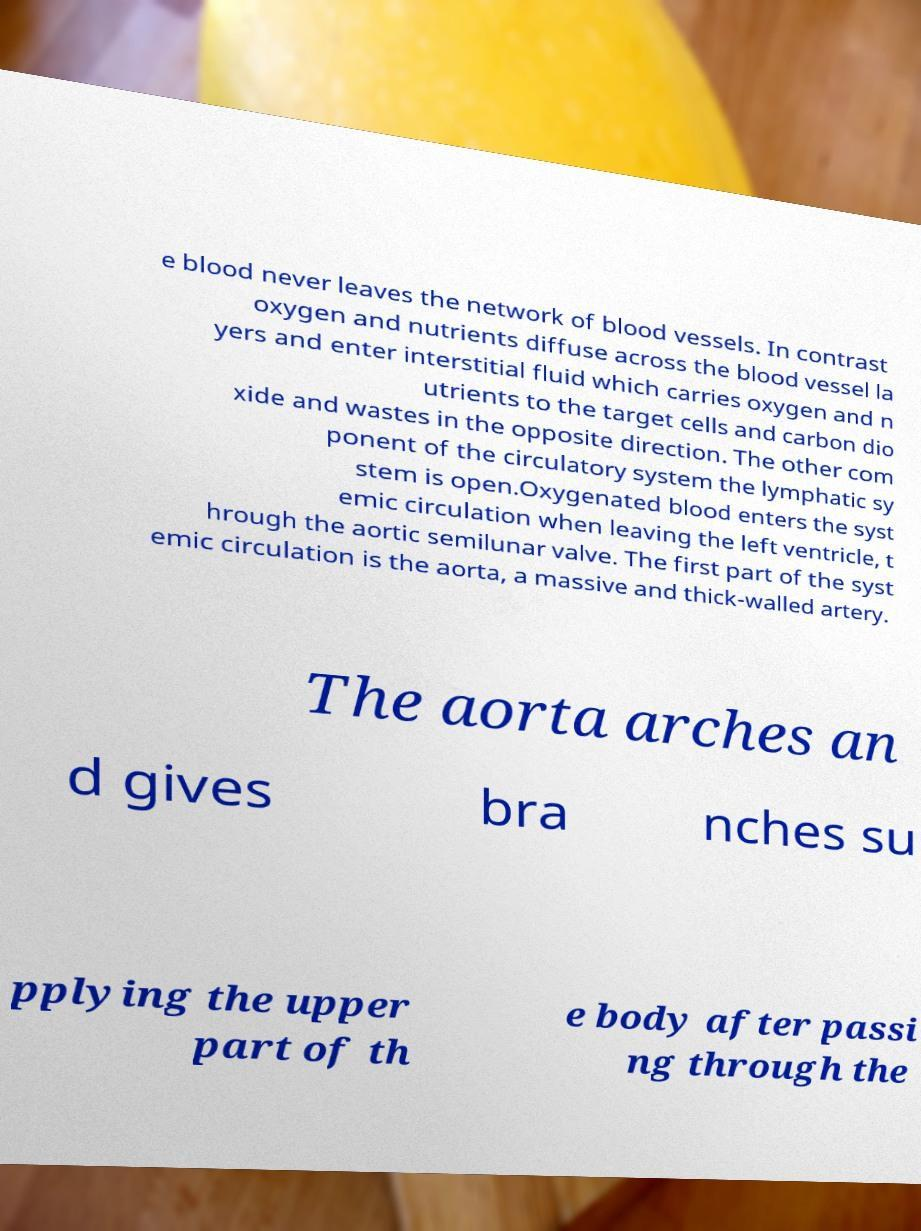For documentation purposes, I need the text within this image transcribed. Could you provide that? e blood never leaves the network of blood vessels. In contrast oxygen and nutrients diffuse across the blood vessel la yers and enter interstitial fluid which carries oxygen and n utrients to the target cells and carbon dio xide and wastes in the opposite direction. The other com ponent of the circulatory system the lymphatic sy stem is open.Oxygenated blood enters the syst emic circulation when leaving the left ventricle, t hrough the aortic semilunar valve. The first part of the syst emic circulation is the aorta, a massive and thick-walled artery. The aorta arches an d gives bra nches su pplying the upper part of th e body after passi ng through the 